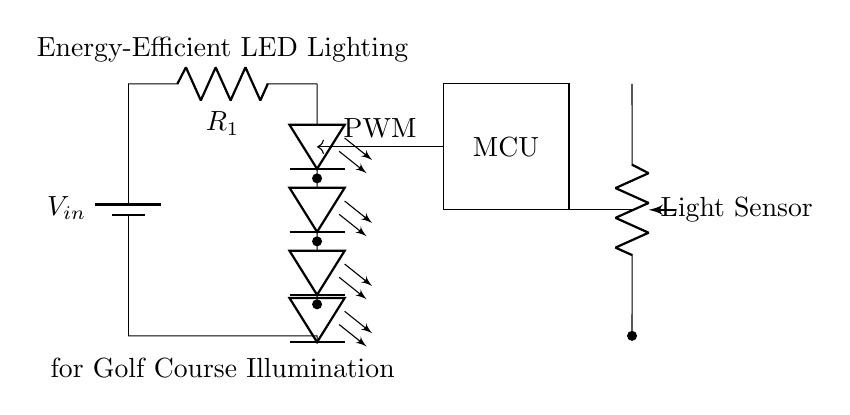What is the power supply component in the circuit? The power supply component is a battery, indicated by the symbol and labeled as V_in. It provides the necessary voltage to power the circuit.
Answer: Battery What does the resistor in the circuit do? The resistor, labeled R_1, is used to limit the current flowing to the LED array, preventing damage to the LEDs from excessive current.
Answer: Current limiting What is the purpose of the light sensor in this circuit? The light sensor detects ambient light levels and communicates with the microcontroller to adjust the brightness of the LED array accordingly.
Answer: Brightness adjustment How many LEDs are there in the array? There are four LEDs connected in series in the LED array, and this is evident by counting the LED symbols in the diagram.
Answer: Four What type of control does the microcontroller use for the LEDs? The microcontroller uses PWM, or pulse-width modulation, to control the brightness of the LEDs by varying the duty cycle of the signal sent to them.
Answer: PWM control What is the significance of the microcontroller's position in the circuit? The microcontroller is positioned to receive input from the light sensor and output PWM signals to control the LEDs, demonstrating its role as the control unit of the lighting system.
Answer: Control unit What is the primary application of this circuit? The primary application of this circuit is to provide energy-efficient illumination for a golf course, as denoted by the labeling on the diagram.
Answer: Golf course illumination 